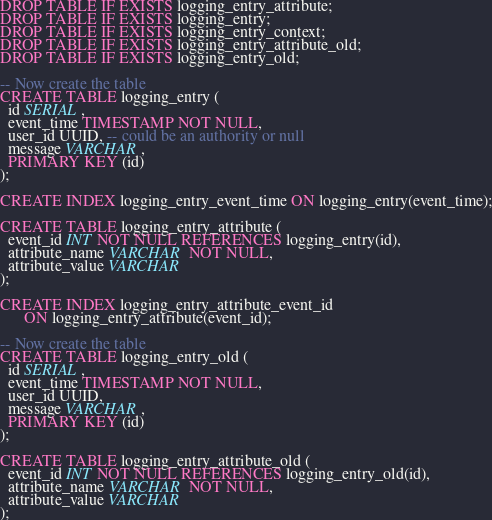Convert code to text. <code><loc_0><loc_0><loc_500><loc_500><_SQL_>DROP TABLE IF EXISTS logging_entry_attribute;
DROP TABLE IF EXISTS logging_entry;
DROP TABLE IF EXISTS logging_entry_context;
DROP TABLE IF EXISTS logging_entry_attribute_old;
DROP TABLE IF EXISTS logging_entry_old;

-- Now create the table
CREATE TABLE logging_entry (
  id SERIAL,
  event_time TIMESTAMP NOT NULL,
  user_id UUID, -- could be an authority or null
  message VARCHAR,
  PRIMARY KEY (id)
);

CREATE INDEX logging_entry_event_time ON logging_entry(event_time);

CREATE TABLE logging_entry_attribute (
  event_id INT NOT NULL REFERENCES logging_entry(id),
  attribute_name VARCHAR NOT NULL,
  attribute_value VARCHAR
);

CREATE INDEX logging_entry_attribute_event_id 
      ON logging_entry_attribute(event_id);

-- Now create the table
CREATE TABLE logging_entry_old (
  id SERIAL,
  event_time TIMESTAMP NOT NULL,
  user_id UUID,
  message VARCHAR,
  PRIMARY KEY (id)
);

CREATE TABLE logging_entry_attribute_old (
  event_id INT NOT NULL REFERENCES logging_entry_old(id),
  attribute_name VARCHAR NOT NULL,
  attribute_value VARCHAR
);

</code> 